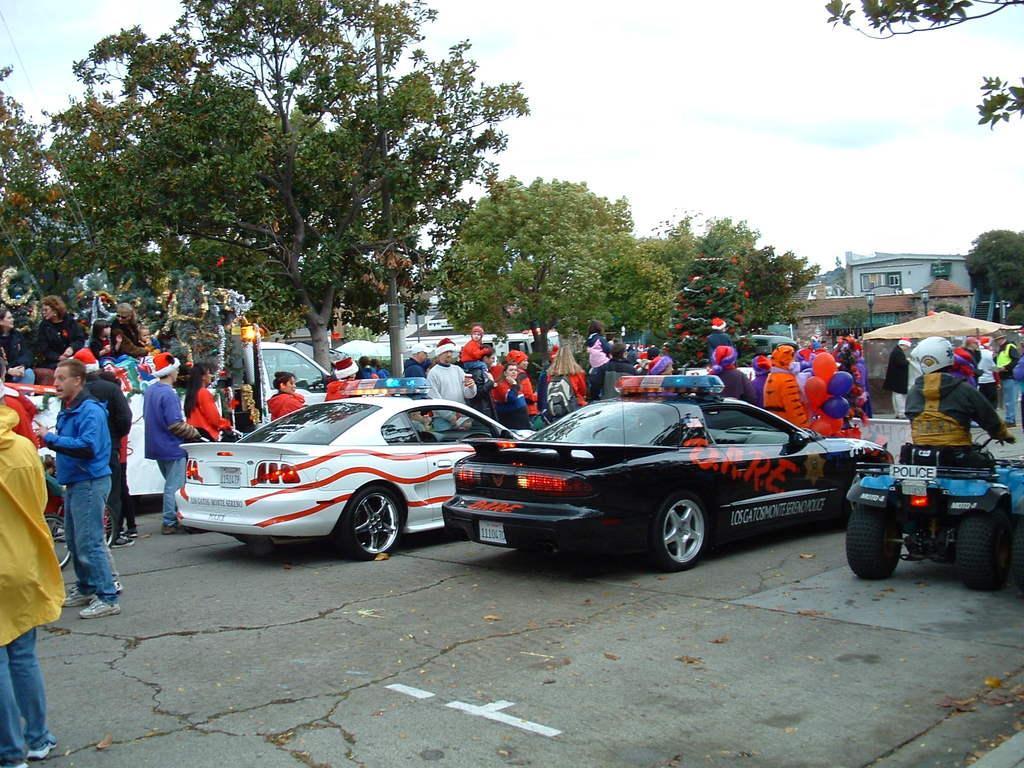How would you summarize this image in a sentence or two? In this picture we can see group of people and few cars, on the left side of the image we can see few people, they are seated in the car, and few people wore caps, in the background we can see few trees, poles, lights and buildings. 